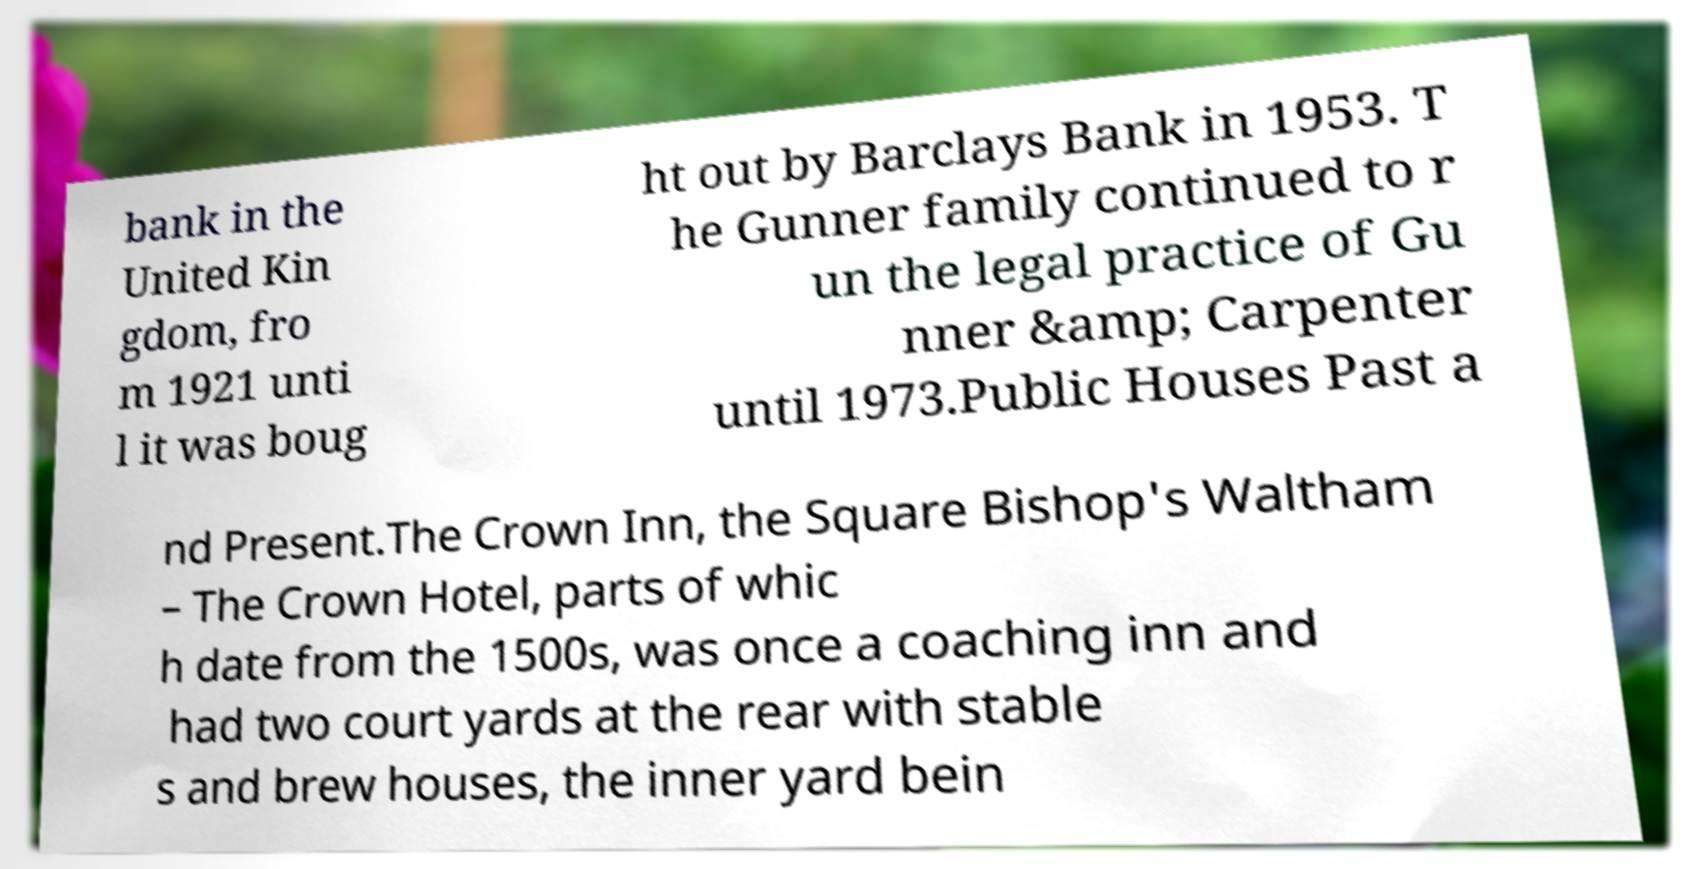Could you extract and type out the text from this image? bank in the United Kin gdom, fro m 1921 unti l it was boug ht out by Barclays Bank in 1953. T he Gunner family continued to r un the legal practice of Gu nner &amp; Carpenter until 1973.Public Houses Past a nd Present.The Crown Inn, the Square Bishop's Waltham – The Crown Hotel, parts of whic h date from the 1500s, was once a coaching inn and had two court yards at the rear with stable s and brew houses, the inner yard bein 